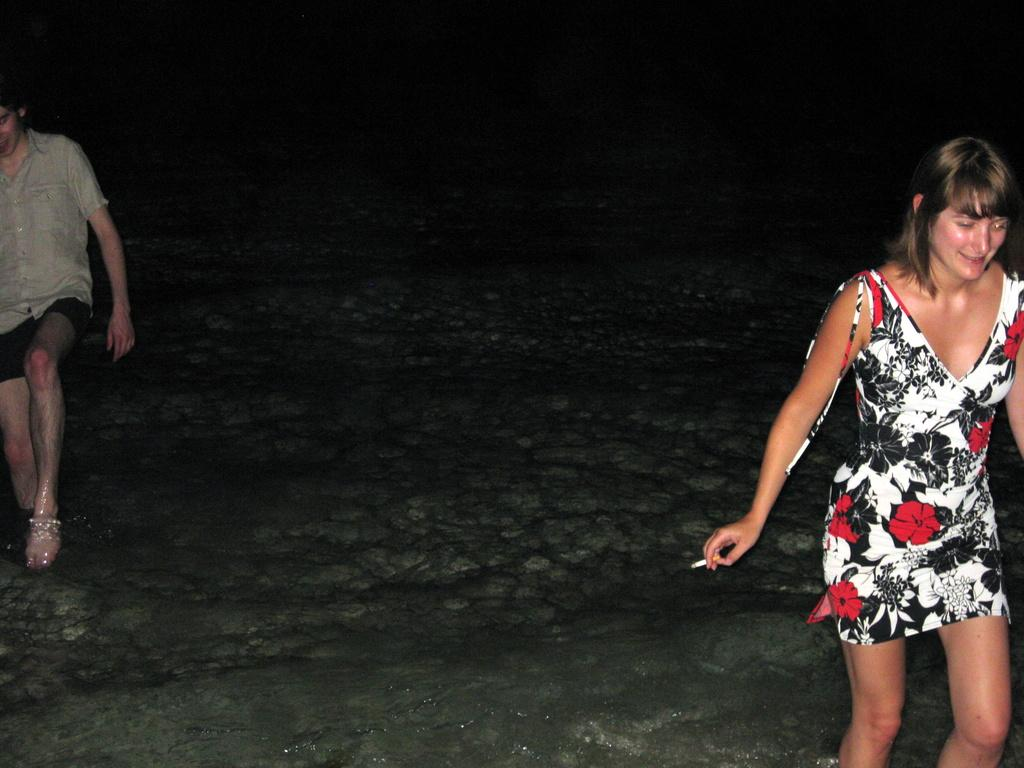Who can be seen in the image? There is a man and a woman in the image. What are the man and woman doing? The man and woman are walking. What can be seen in the background of the image? There is water visible in the image. What is the woman holding in her hand? The woman is holding a cigarette in her hand. What type of punishment is being administered to the man in the image? There is no punishment being administered to the man in the image; he is simply walking with the woman. What sound can be heard coming from the bell in the image? There is no bell present in the image. 